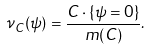<formula> <loc_0><loc_0><loc_500><loc_500>\nu _ { C } ( \psi ) = \frac { C \cdot \{ \psi = 0 \} } { m ( C ) } .</formula> 